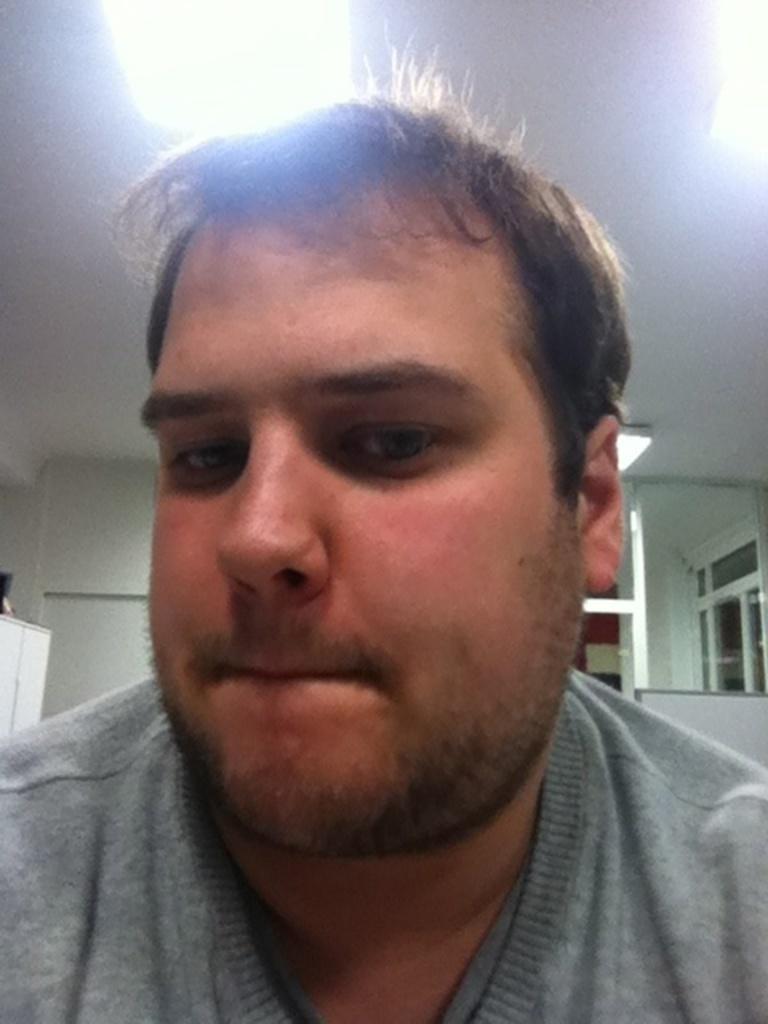Could you give a brief overview of what you see in this image? In this picture we can see a man and in the background we can see the wall, ceiling, some objects. 